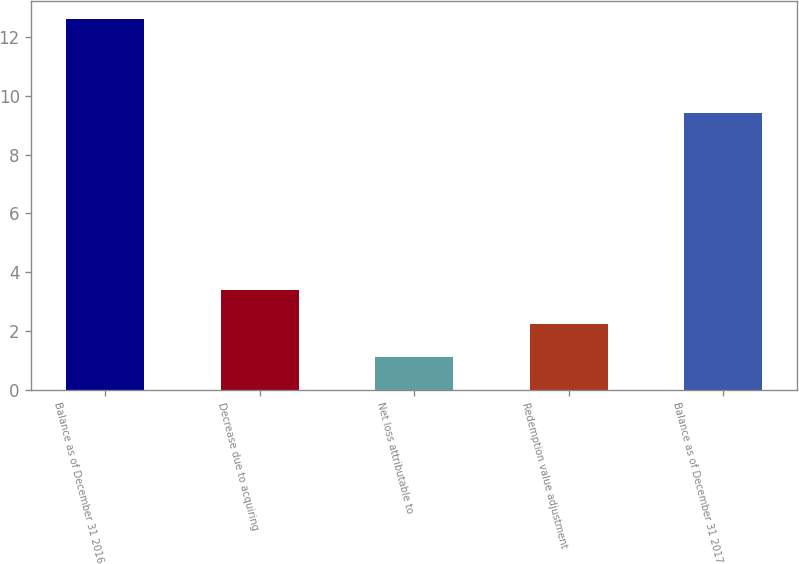<chart> <loc_0><loc_0><loc_500><loc_500><bar_chart><fcel>Balance as of December 31 2016<fcel>Decrease due to acquiring<fcel>Net loss attributable to<fcel>Redemption value adjustment<fcel>Balance as of December 31 2017<nl><fcel>12.6<fcel>3.4<fcel>1.1<fcel>2.25<fcel>9.4<nl></chart> 